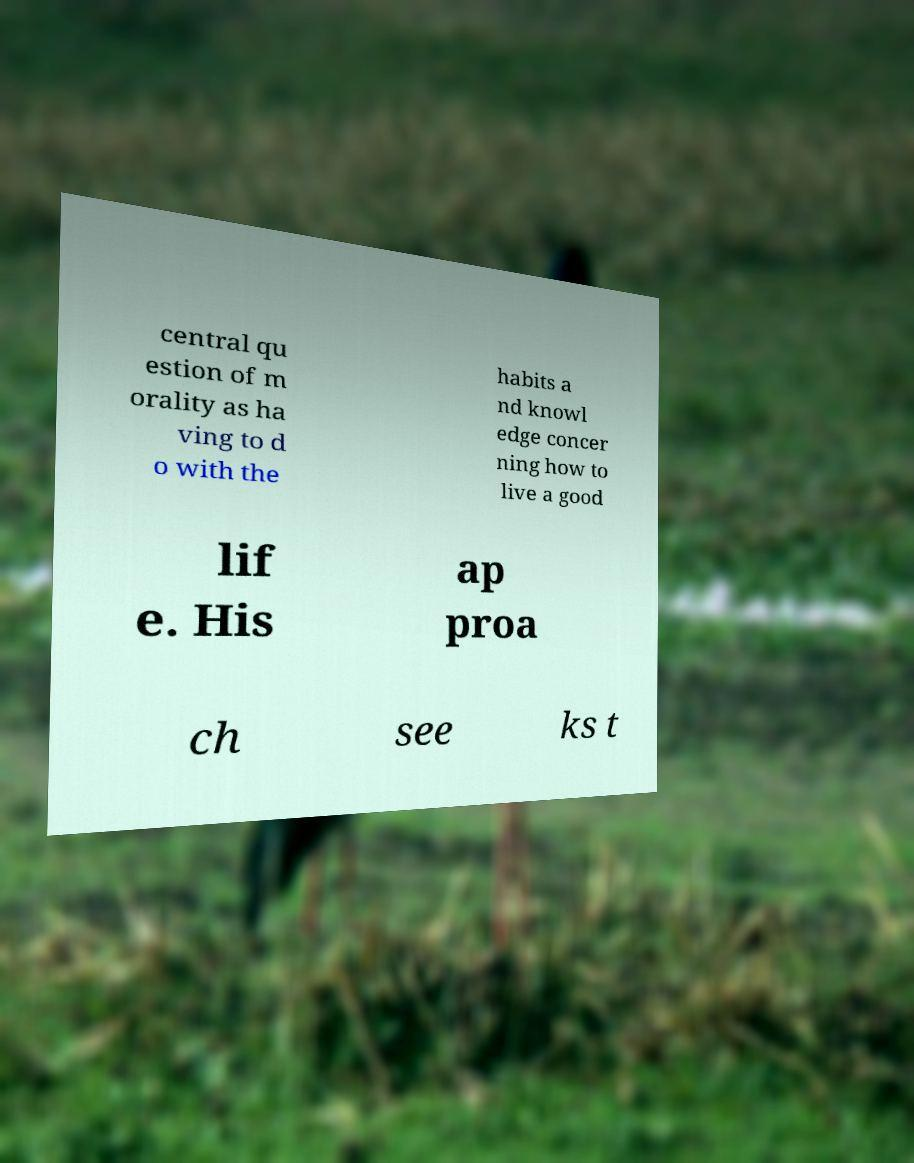Please read and relay the text visible in this image. What does it say? central qu estion of m orality as ha ving to d o with the habits a nd knowl edge concer ning how to live a good lif e. His ap proa ch see ks t 